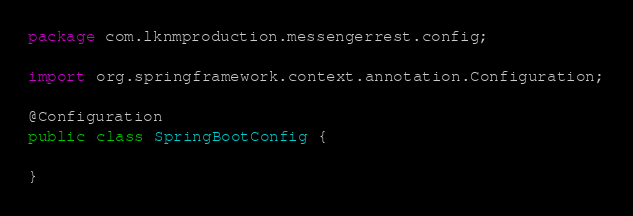<code> <loc_0><loc_0><loc_500><loc_500><_Java_>package com.lknmproduction.messengerrest.config;

import org.springframework.context.annotation.Configuration;

@Configuration
public class SpringBootConfig {

}
</code> 